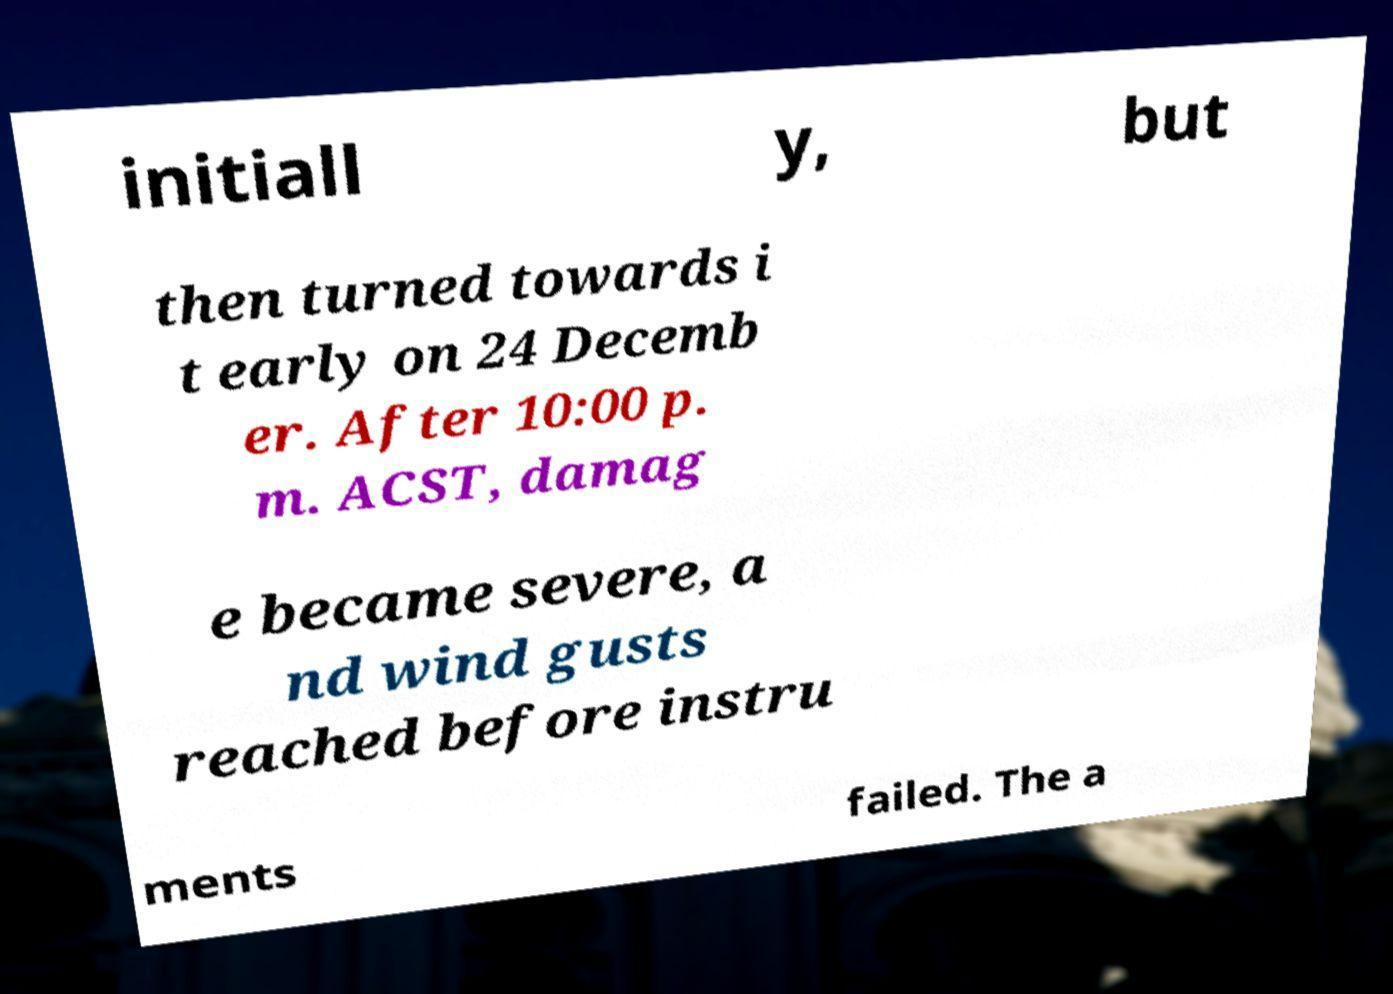Can you accurately transcribe the text from the provided image for me? initiall y, but then turned towards i t early on 24 Decemb er. After 10:00 p. m. ACST, damag e became severe, a nd wind gusts reached before instru ments failed. The a 